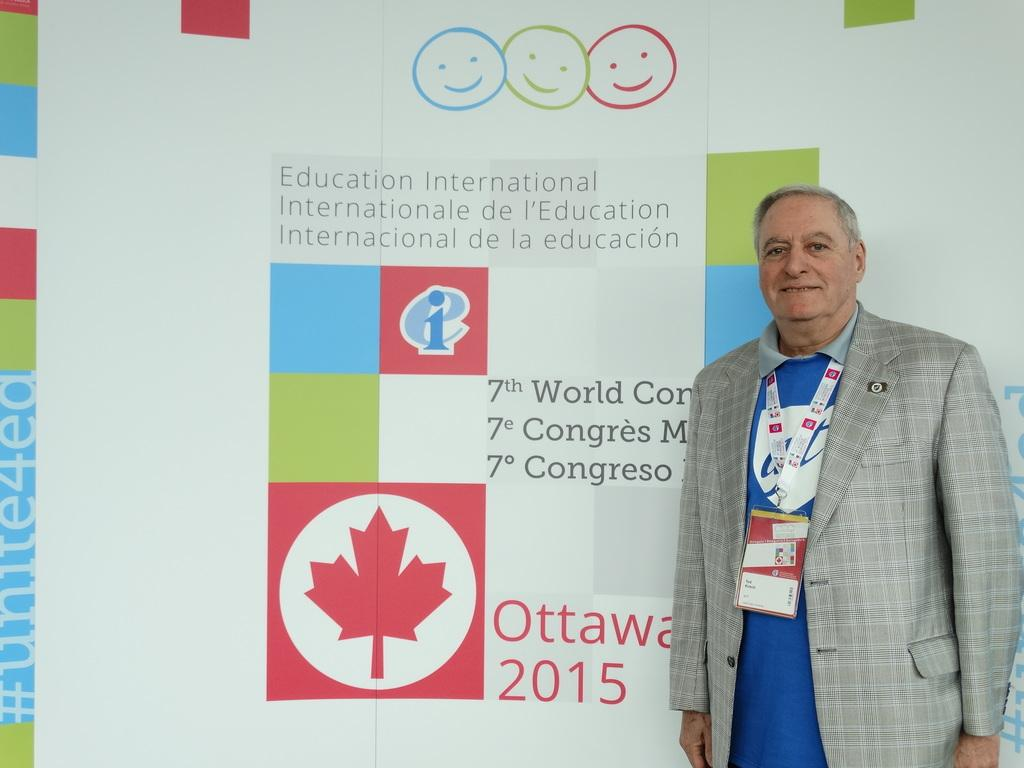What is the main subject of the image? There is a person in the image. What is the person doing in the image? The person is standing in the image. What expression does the person have? The person is smiling in the image. What can be seen behind the person? There is a banner behind the person. What type of pollution can be seen in the image? There is no pollution visible in the image; it features a person standing and smiling with a banner behind them. What does the person's body smell like in the image? There is no information about the person's body or smell in the image. 